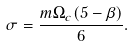Convert formula to latex. <formula><loc_0><loc_0><loc_500><loc_500>\sigma = \frac { m \Omega _ { c } ( 5 - \beta ) } { 6 } .</formula> 